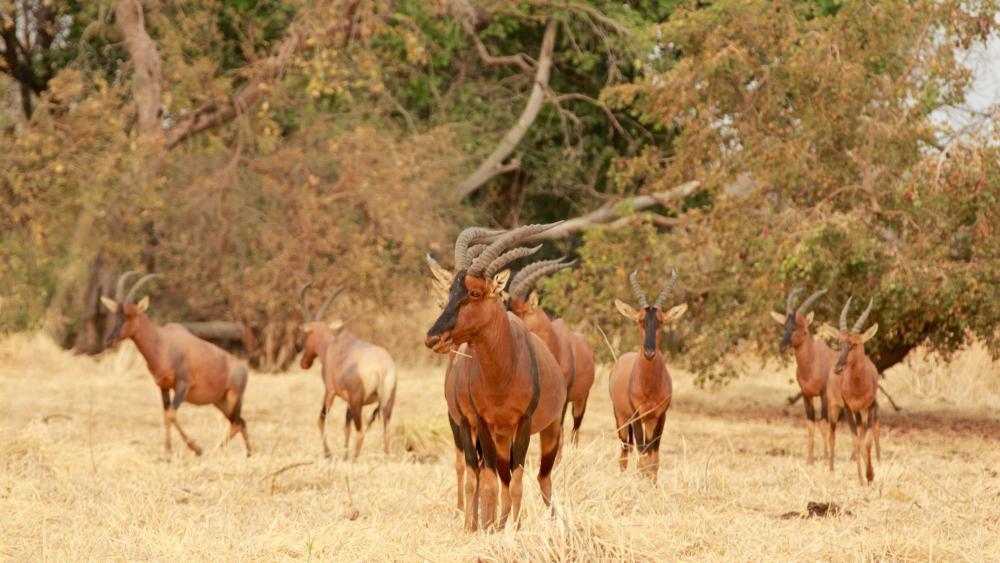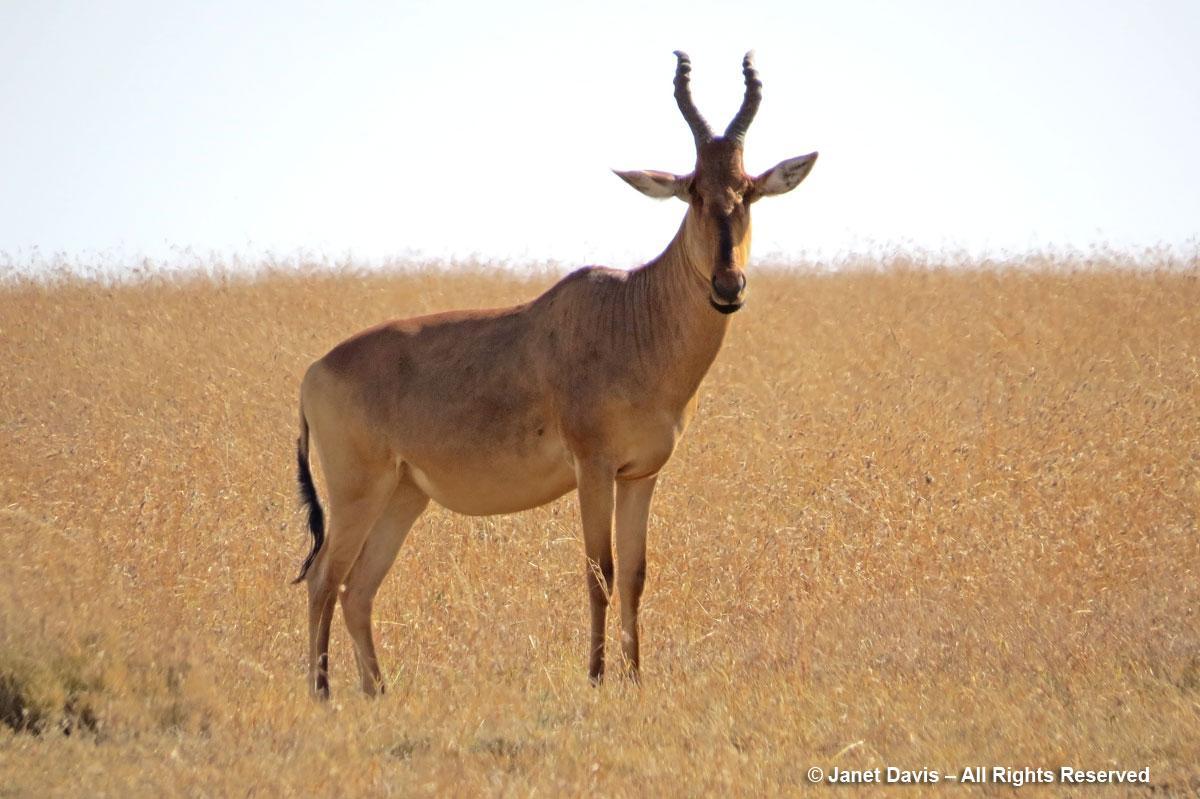The first image is the image on the left, the second image is the image on the right. Analyze the images presented: Is the assertion "One of the images shows exactly one antelope." valid? Answer yes or no. Yes. The first image is the image on the left, the second image is the image on the right. Given the left and right images, does the statement "An image features exactly one horned animal, and it looks toward the camera." hold true? Answer yes or no. Yes. 